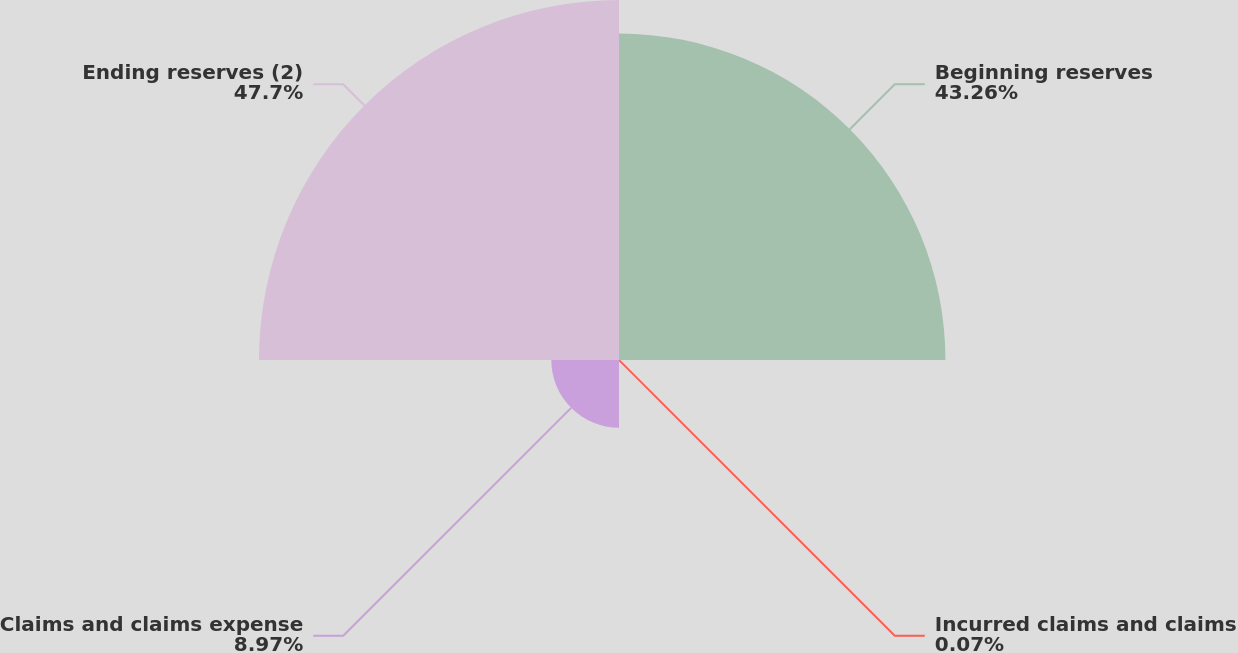<chart> <loc_0><loc_0><loc_500><loc_500><pie_chart><fcel>Beginning reserves<fcel>Incurred claims and claims<fcel>Claims and claims expense<fcel>Ending reserves (2)<nl><fcel>43.26%<fcel>0.07%<fcel>8.97%<fcel>47.71%<nl></chart> 